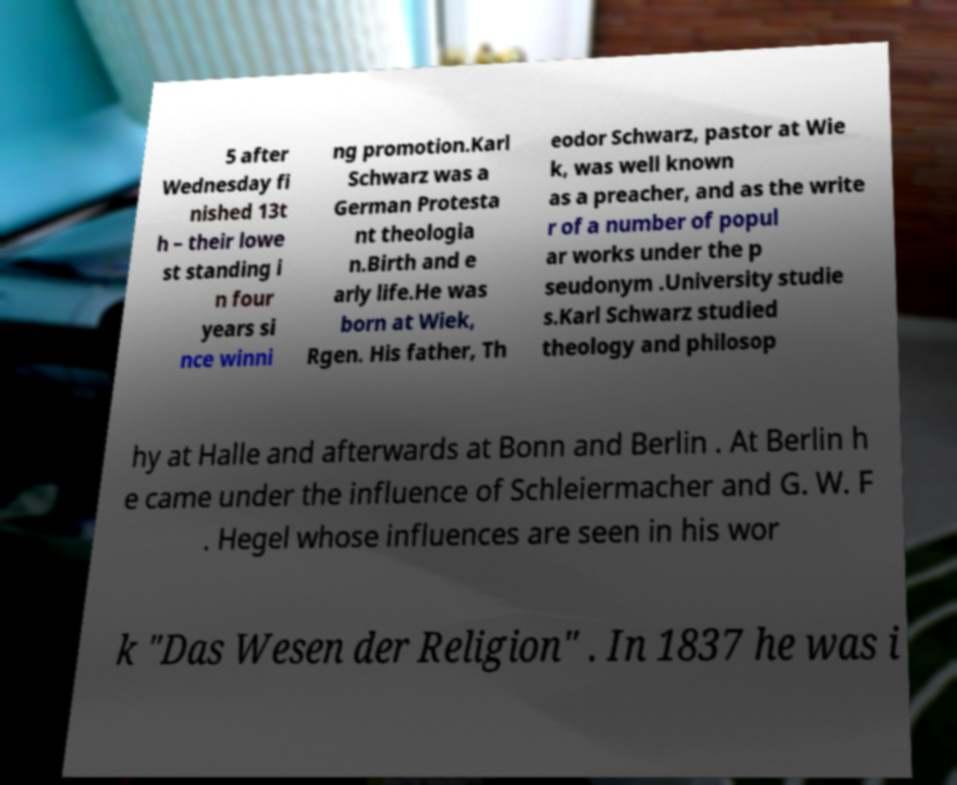Can you read and provide the text displayed in the image?This photo seems to have some interesting text. Can you extract and type it out for me? 5 after Wednesday fi nished 13t h – their lowe st standing i n four years si nce winni ng promotion.Karl Schwarz was a German Protesta nt theologia n.Birth and e arly life.He was born at Wiek, Rgen. His father, Th eodor Schwarz, pastor at Wie k, was well known as a preacher, and as the write r of a number of popul ar works under the p seudonym .University studie s.Karl Schwarz studied theology and philosop hy at Halle and afterwards at Bonn and Berlin . At Berlin h e came under the influence of Schleiermacher and G. W. F . Hegel whose influences are seen in his wor k "Das Wesen der Religion" . In 1837 he was i 